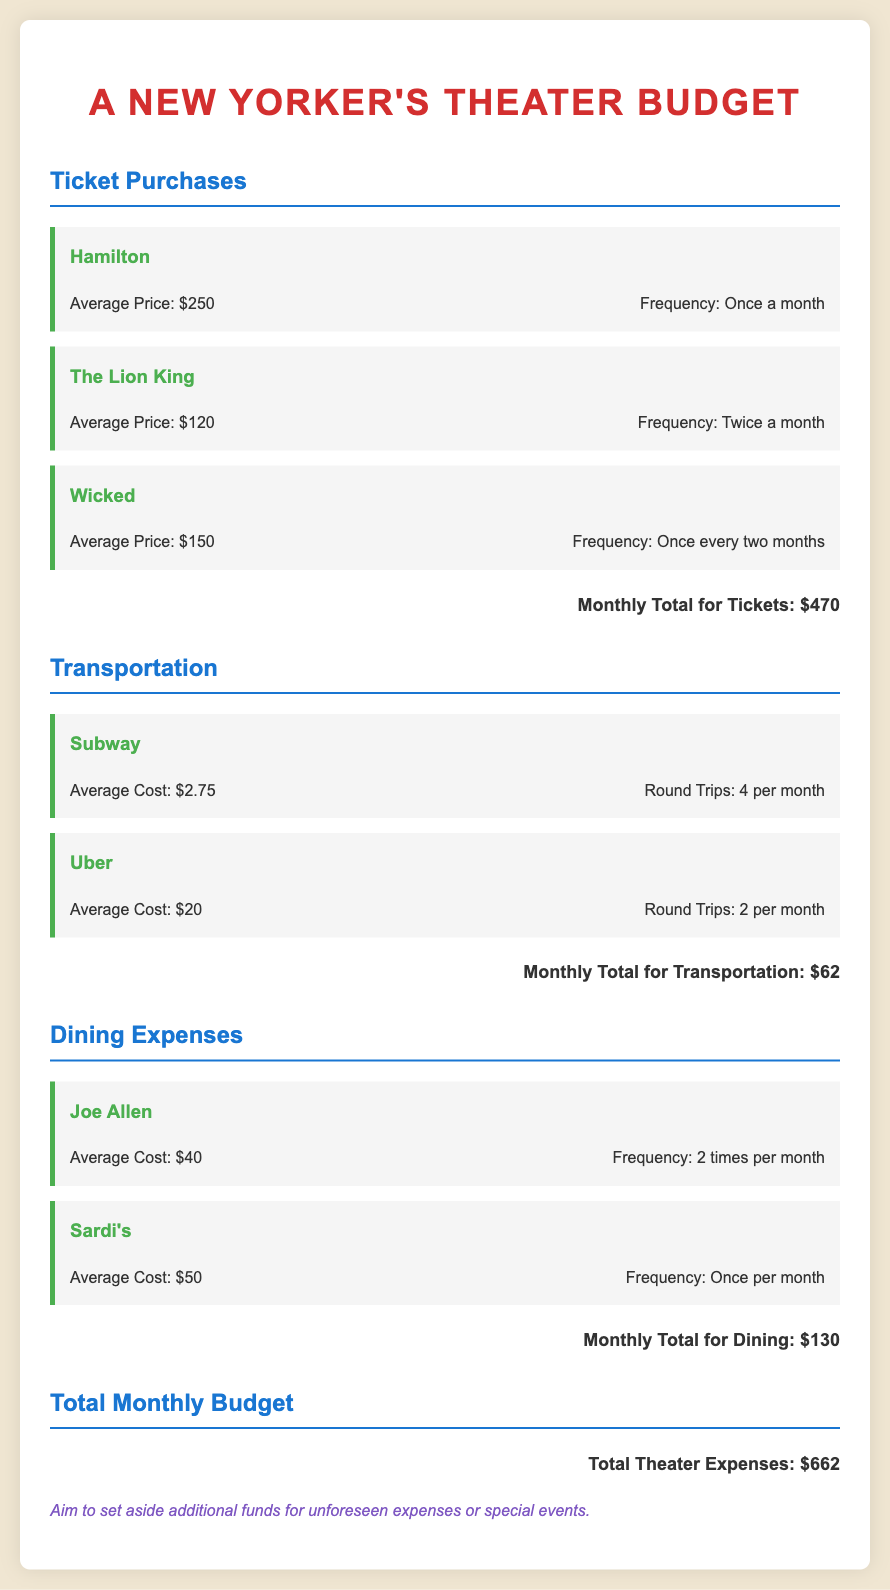What is the average price of Hamilton tickets? The average price for Hamilton tickets is mentioned in the document as $250.
Answer: $250 How many times a month is The Lion King attended? The document states that The Lion King tickets are purchased twice a month.
Answer: Twice a month What is the total monthly budget for transportation? The total monthly budget for transportation is calculated and presented as $62 in the document.
Answer: $62 How much is spent on Joe Allen per month? The document indicates that Joe Allen is visited 2 times per month at an average cost of $40 each time, totaling $80, but the monthly total is provided as $130.
Answer: $130 What is the total for all theater-related expenses? The document sums up all expenses to state the total theater expenses amount as $662.
Answer: $662 Which dining expense has the highest average cost? Among the mentioned dining expenses, Sardi's has the highest average cost of $50.
Answer: Sardi's What is the frequency of attending Wicked? The document specifies that Wicked is attended once every two months.
Answer: Once every two months How many round trips are made using Uber? The document states there are 2 round trips made using Uber per month.
Answer: 2 per month What suggestion is made regarding the budget? The document recommends aiming to set aside additional funds for unforeseen expenses or special events.
Answer: Additional funds for unforeseen expenses 